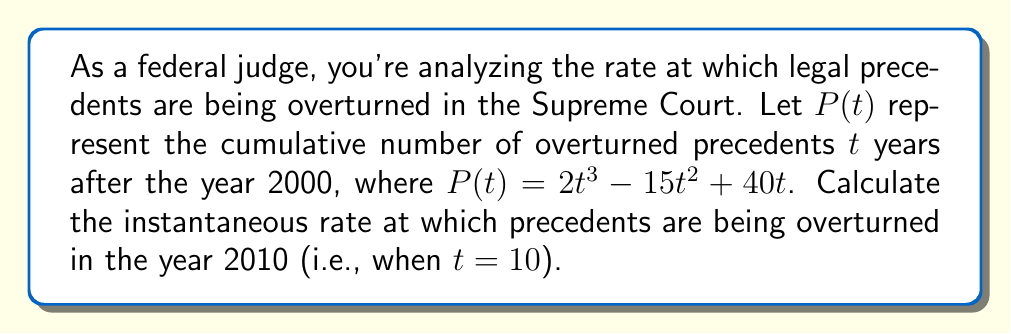Show me your answer to this math problem. To find the instantaneous rate at which precedents are being overturned, we need to calculate the derivative of $P(t)$ and evaluate it at $t = 10$. This process involves the following steps:

1) First, let's find the derivative of $P(t)$:
   $P(t) = 2t^3 - 15t^2 + 40t$
   $P'(t) = \frac{d}{dt}(2t^3 - 15t^2 + 40t)$
   $P'(t) = 6t^2 - 30t + 40$

2) Now that we have the derivative, we can interpret $P'(t)$ as the instantaneous rate of change in the number of overturned precedents at any time $t$.

3) To find the rate in 2010, we need to evaluate $P'(t)$ at $t = 10$:
   $P'(10) = 6(10)^2 - 30(10) + 40$
   $P'(10) = 600 - 300 + 40$
   $P'(10) = 340$

Therefore, in the year 2010, precedents were being overturned at a rate of 340 per year.
Answer: 340 precedents per year 